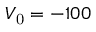Convert formula to latex. <formula><loc_0><loc_0><loc_500><loc_500>V _ { 0 } = - 1 0 0</formula> 